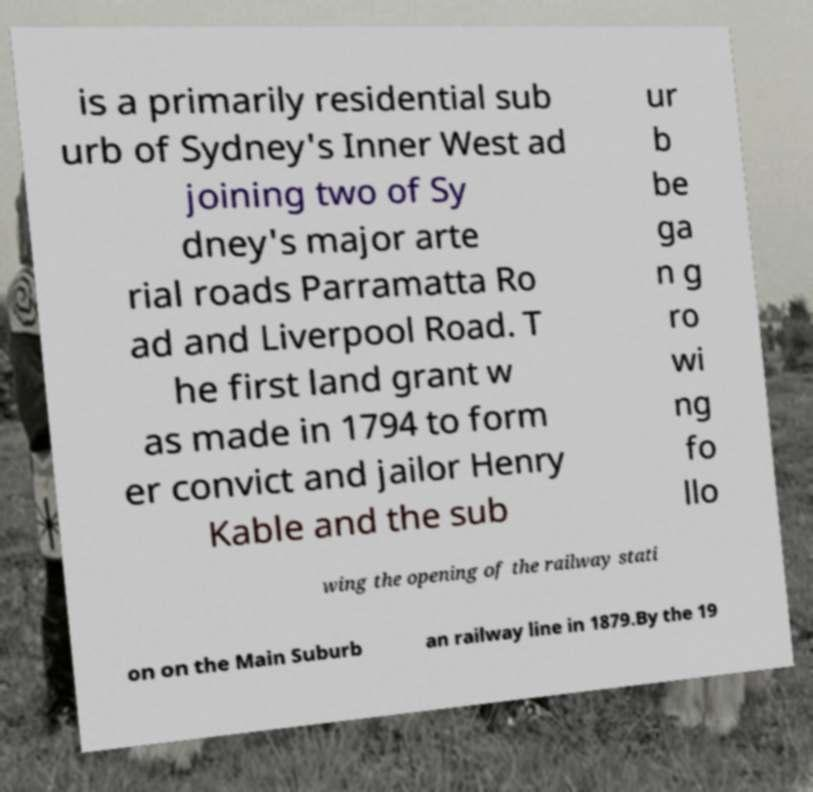Could you assist in decoding the text presented in this image and type it out clearly? is a primarily residential sub urb of Sydney's Inner West ad joining two of Sy dney's major arte rial roads Parramatta Ro ad and Liverpool Road. T he first land grant w as made in 1794 to form er convict and jailor Henry Kable and the sub ur b be ga n g ro wi ng fo llo wing the opening of the railway stati on on the Main Suburb an railway line in 1879.By the 19 